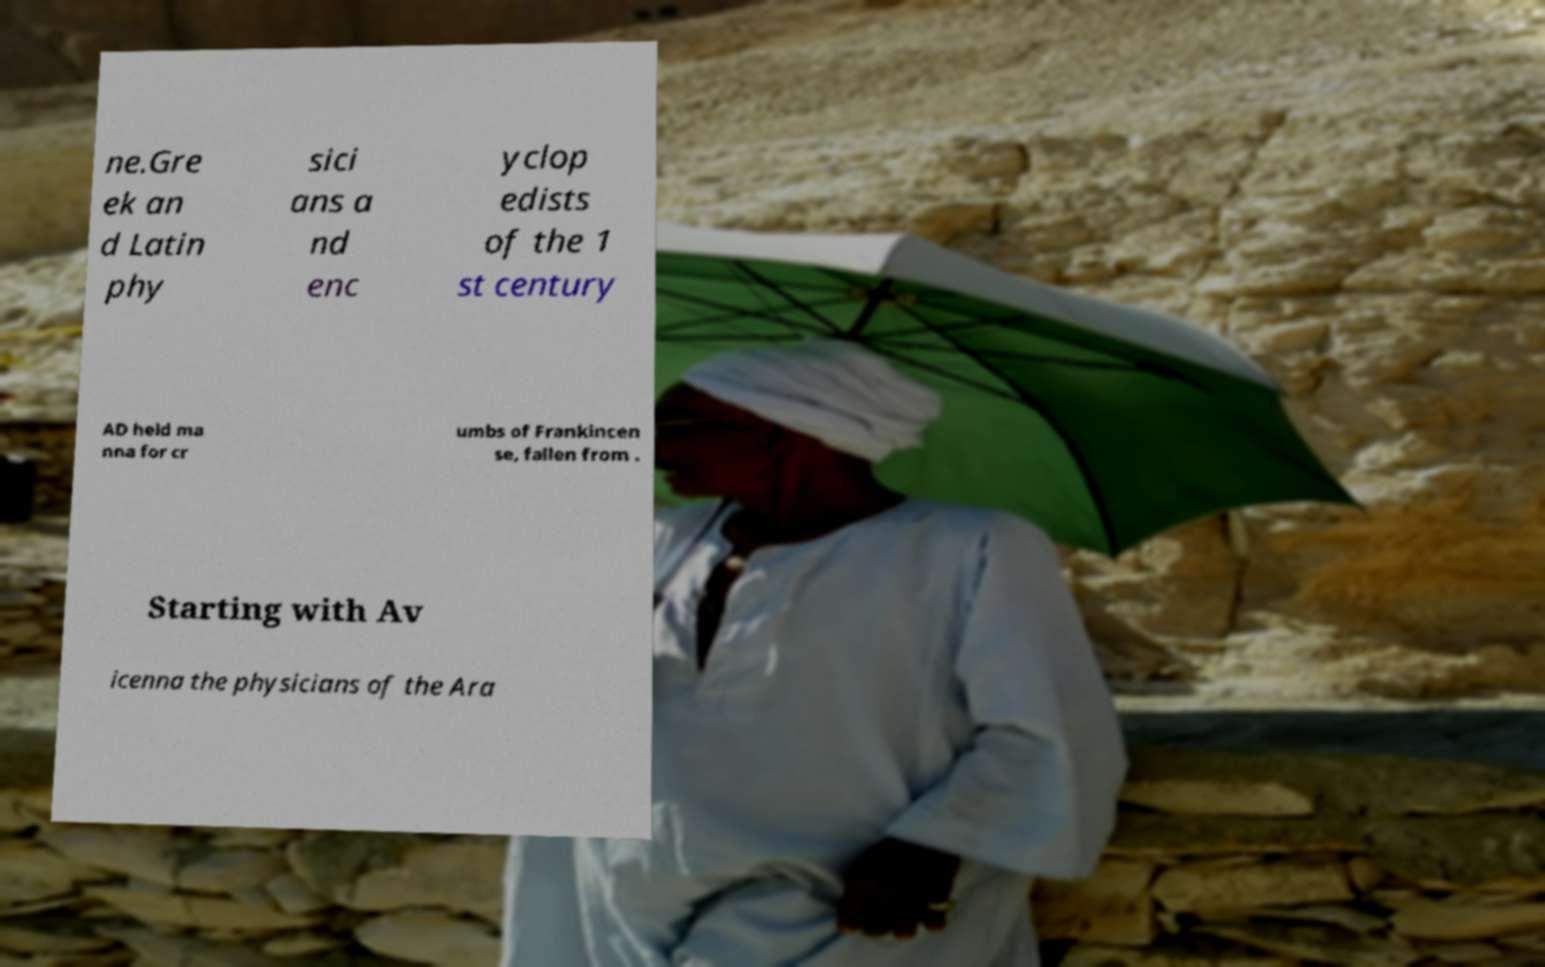I need the written content from this picture converted into text. Can you do that? ne.Gre ek an d Latin phy sici ans a nd enc yclop edists of the 1 st century AD held ma nna for cr umbs of Frankincen se, fallen from . Starting with Av icenna the physicians of the Ara 